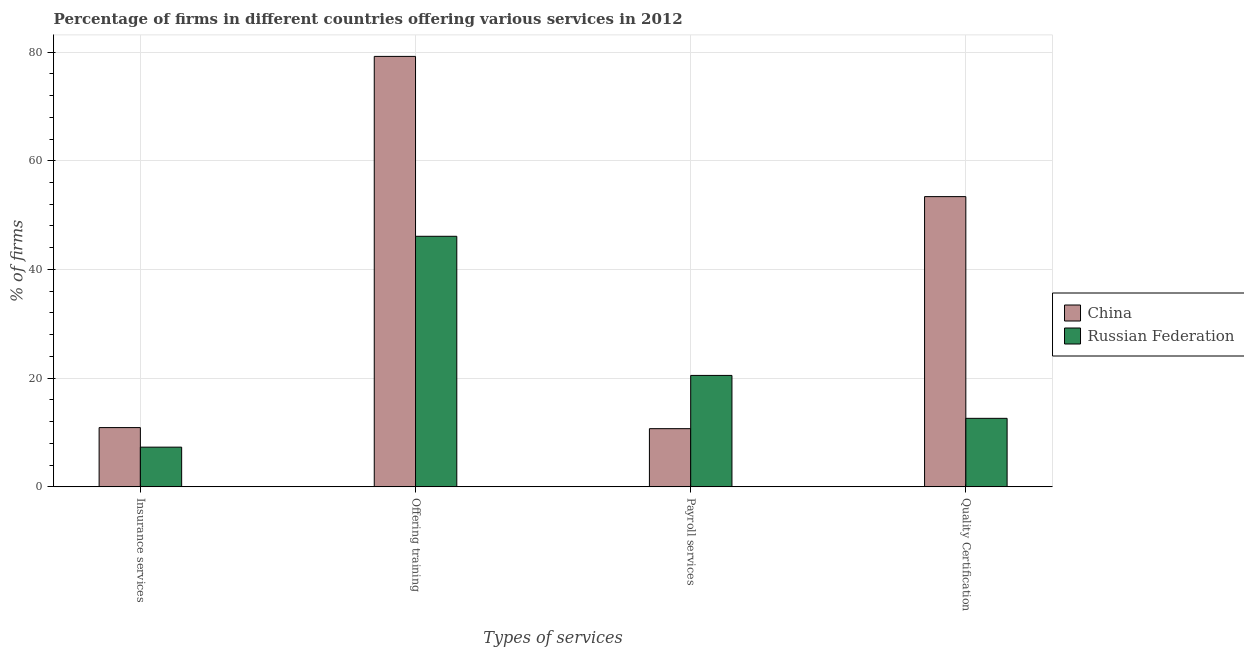Are the number of bars on each tick of the X-axis equal?
Your answer should be very brief. Yes. How many bars are there on the 1st tick from the right?
Provide a succinct answer. 2. What is the label of the 1st group of bars from the left?
Give a very brief answer. Insurance services. What is the percentage of firms offering insurance services in China?
Provide a short and direct response. 10.9. Across all countries, what is the maximum percentage of firms offering quality certification?
Give a very brief answer. 53.4. Across all countries, what is the minimum percentage of firms offering training?
Provide a succinct answer. 46.1. In which country was the percentage of firms offering training minimum?
Provide a short and direct response. Russian Federation. What is the total percentage of firms offering insurance services in the graph?
Your answer should be compact. 18.2. What is the difference between the percentage of firms offering insurance services in China and that in Russian Federation?
Your response must be concise. 3.6. What is the difference between the percentage of firms offering quality certification in Russian Federation and the percentage of firms offering insurance services in China?
Ensure brevity in your answer.  1.7. What is the average percentage of firms offering training per country?
Provide a succinct answer. 62.65. What is the difference between the percentage of firms offering training and percentage of firms offering payroll services in China?
Keep it short and to the point. 68.5. What is the ratio of the percentage of firms offering quality certification in China to that in Russian Federation?
Provide a succinct answer. 4.24. What is the difference between the highest and the second highest percentage of firms offering quality certification?
Keep it short and to the point. 40.8. In how many countries, is the percentage of firms offering quality certification greater than the average percentage of firms offering quality certification taken over all countries?
Provide a short and direct response. 1. What does the 2nd bar from the left in Insurance services represents?
Offer a terse response. Russian Federation. Are all the bars in the graph horizontal?
Your answer should be very brief. No. What is the difference between two consecutive major ticks on the Y-axis?
Your response must be concise. 20. Are the values on the major ticks of Y-axis written in scientific E-notation?
Keep it short and to the point. No. Does the graph contain any zero values?
Provide a succinct answer. No. How many legend labels are there?
Keep it short and to the point. 2. What is the title of the graph?
Your answer should be very brief. Percentage of firms in different countries offering various services in 2012. Does "Argentina" appear as one of the legend labels in the graph?
Make the answer very short. No. What is the label or title of the X-axis?
Keep it short and to the point. Types of services. What is the label or title of the Y-axis?
Ensure brevity in your answer.  % of firms. What is the % of firms in China in Offering training?
Ensure brevity in your answer.  79.2. What is the % of firms in Russian Federation in Offering training?
Your answer should be very brief. 46.1. What is the % of firms of Russian Federation in Payroll services?
Keep it short and to the point. 20.5. What is the % of firms of China in Quality Certification?
Make the answer very short. 53.4. Across all Types of services, what is the maximum % of firms in China?
Provide a short and direct response. 79.2. Across all Types of services, what is the maximum % of firms in Russian Federation?
Your answer should be very brief. 46.1. Across all Types of services, what is the minimum % of firms of China?
Offer a terse response. 10.7. What is the total % of firms of China in the graph?
Your answer should be very brief. 154.2. What is the total % of firms in Russian Federation in the graph?
Give a very brief answer. 86.5. What is the difference between the % of firms in China in Insurance services and that in Offering training?
Give a very brief answer. -68.3. What is the difference between the % of firms in Russian Federation in Insurance services and that in Offering training?
Make the answer very short. -38.8. What is the difference between the % of firms in China in Insurance services and that in Payroll services?
Provide a short and direct response. 0.2. What is the difference between the % of firms of China in Insurance services and that in Quality Certification?
Your answer should be very brief. -42.5. What is the difference between the % of firms in Russian Federation in Insurance services and that in Quality Certification?
Keep it short and to the point. -5.3. What is the difference between the % of firms in China in Offering training and that in Payroll services?
Provide a short and direct response. 68.5. What is the difference between the % of firms of Russian Federation in Offering training and that in Payroll services?
Your response must be concise. 25.6. What is the difference between the % of firms in China in Offering training and that in Quality Certification?
Offer a terse response. 25.8. What is the difference between the % of firms of Russian Federation in Offering training and that in Quality Certification?
Your answer should be very brief. 33.5. What is the difference between the % of firms of China in Payroll services and that in Quality Certification?
Your answer should be compact. -42.7. What is the difference between the % of firms of China in Insurance services and the % of firms of Russian Federation in Offering training?
Provide a short and direct response. -35.2. What is the difference between the % of firms in China in Insurance services and the % of firms in Russian Federation in Payroll services?
Your response must be concise. -9.6. What is the difference between the % of firms of China in Offering training and the % of firms of Russian Federation in Payroll services?
Provide a succinct answer. 58.7. What is the difference between the % of firms in China in Offering training and the % of firms in Russian Federation in Quality Certification?
Your response must be concise. 66.6. What is the average % of firms of China per Types of services?
Provide a succinct answer. 38.55. What is the average % of firms of Russian Federation per Types of services?
Offer a terse response. 21.62. What is the difference between the % of firms in China and % of firms in Russian Federation in Insurance services?
Offer a very short reply. 3.6. What is the difference between the % of firms of China and % of firms of Russian Federation in Offering training?
Make the answer very short. 33.1. What is the difference between the % of firms of China and % of firms of Russian Federation in Quality Certification?
Keep it short and to the point. 40.8. What is the ratio of the % of firms in China in Insurance services to that in Offering training?
Make the answer very short. 0.14. What is the ratio of the % of firms in Russian Federation in Insurance services to that in Offering training?
Your answer should be very brief. 0.16. What is the ratio of the % of firms of China in Insurance services to that in Payroll services?
Give a very brief answer. 1.02. What is the ratio of the % of firms of Russian Federation in Insurance services to that in Payroll services?
Make the answer very short. 0.36. What is the ratio of the % of firms in China in Insurance services to that in Quality Certification?
Offer a terse response. 0.2. What is the ratio of the % of firms in Russian Federation in Insurance services to that in Quality Certification?
Provide a succinct answer. 0.58. What is the ratio of the % of firms in China in Offering training to that in Payroll services?
Your answer should be very brief. 7.4. What is the ratio of the % of firms of Russian Federation in Offering training to that in Payroll services?
Your response must be concise. 2.25. What is the ratio of the % of firms of China in Offering training to that in Quality Certification?
Provide a succinct answer. 1.48. What is the ratio of the % of firms of Russian Federation in Offering training to that in Quality Certification?
Offer a very short reply. 3.66. What is the ratio of the % of firms in China in Payroll services to that in Quality Certification?
Your answer should be very brief. 0.2. What is the ratio of the % of firms in Russian Federation in Payroll services to that in Quality Certification?
Keep it short and to the point. 1.63. What is the difference between the highest and the second highest % of firms in China?
Provide a short and direct response. 25.8. What is the difference between the highest and the second highest % of firms in Russian Federation?
Provide a succinct answer. 25.6. What is the difference between the highest and the lowest % of firms of China?
Provide a short and direct response. 68.5. What is the difference between the highest and the lowest % of firms in Russian Federation?
Your answer should be very brief. 38.8. 